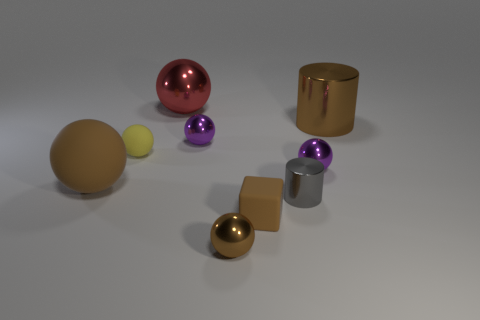Subtract 2 spheres. How many spheres are left? 4 Subtract all yellow balls. How many balls are left? 5 Subtract all brown spheres. How many spheres are left? 4 Subtract all blue spheres. Subtract all gray cylinders. How many spheres are left? 6 Add 1 gray objects. How many objects exist? 10 Subtract all cylinders. How many objects are left? 7 Add 1 tiny objects. How many tiny objects exist? 7 Subtract 1 brown cylinders. How many objects are left? 8 Subtract all small brown rubber cubes. Subtract all large red things. How many objects are left? 7 Add 8 large red metallic things. How many large red metallic things are left? 9 